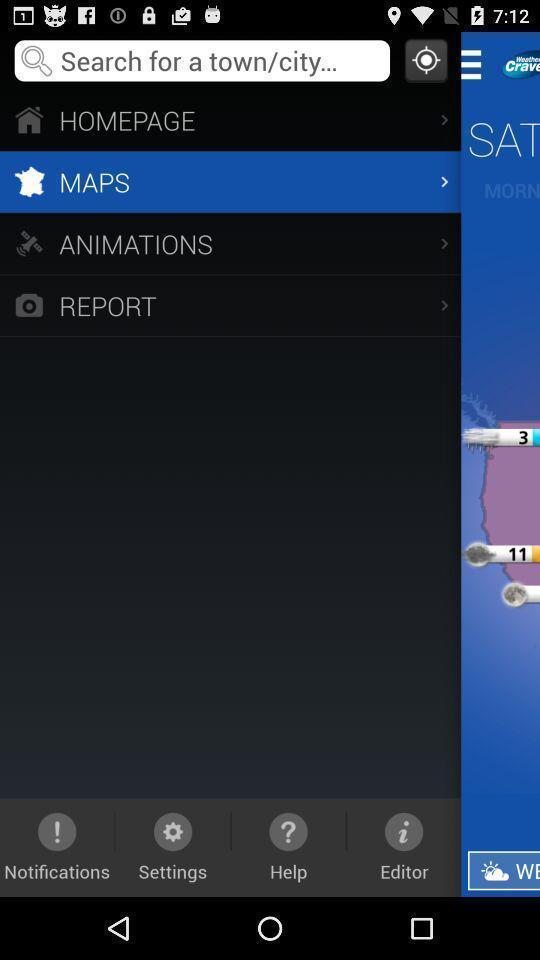Provide a textual representation of this image. Social app for searching purpose. 